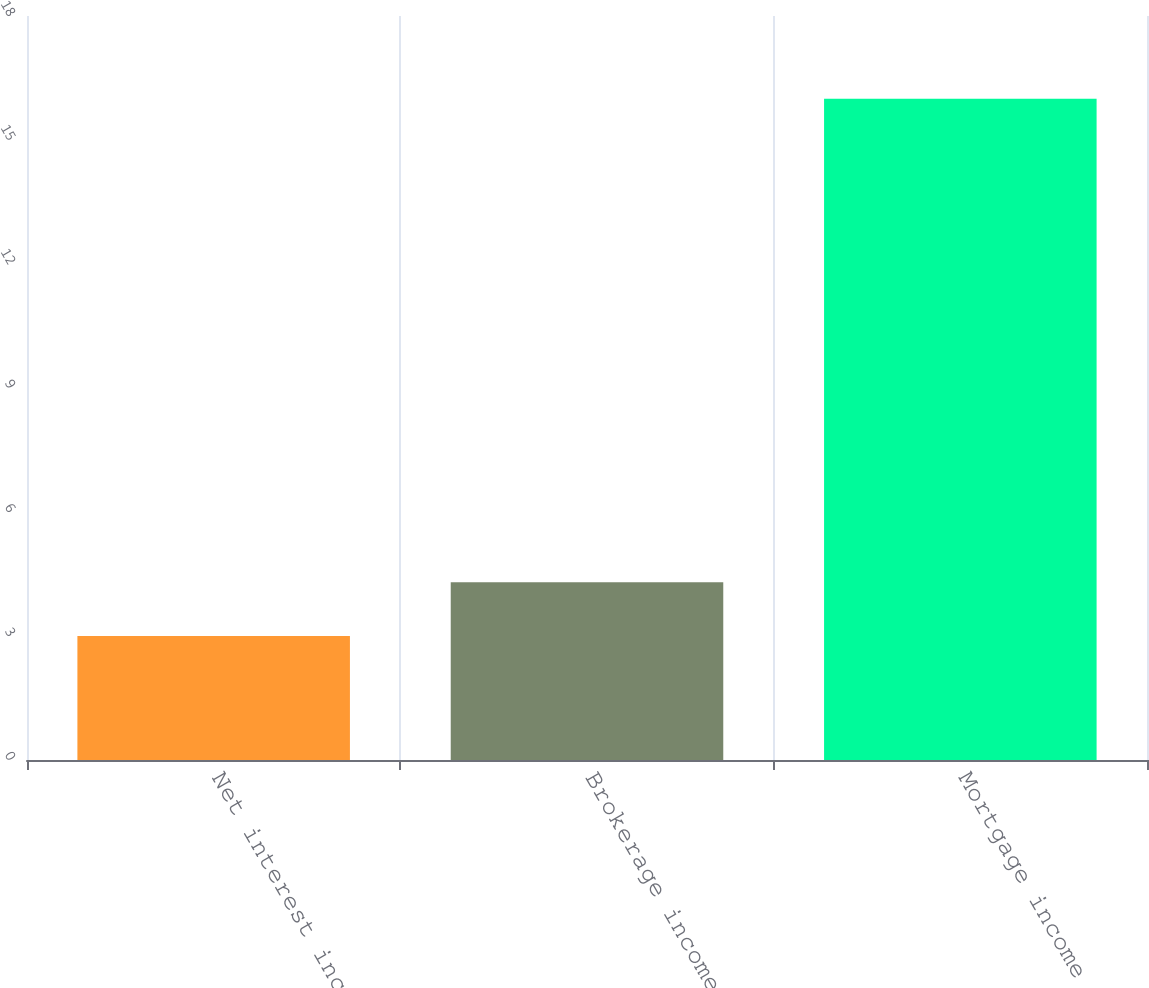Convert chart. <chart><loc_0><loc_0><loc_500><loc_500><bar_chart><fcel>Net interest income<fcel>Brokerage income<fcel>Mortgage income<nl><fcel>3<fcel>4.3<fcel>16<nl></chart> 